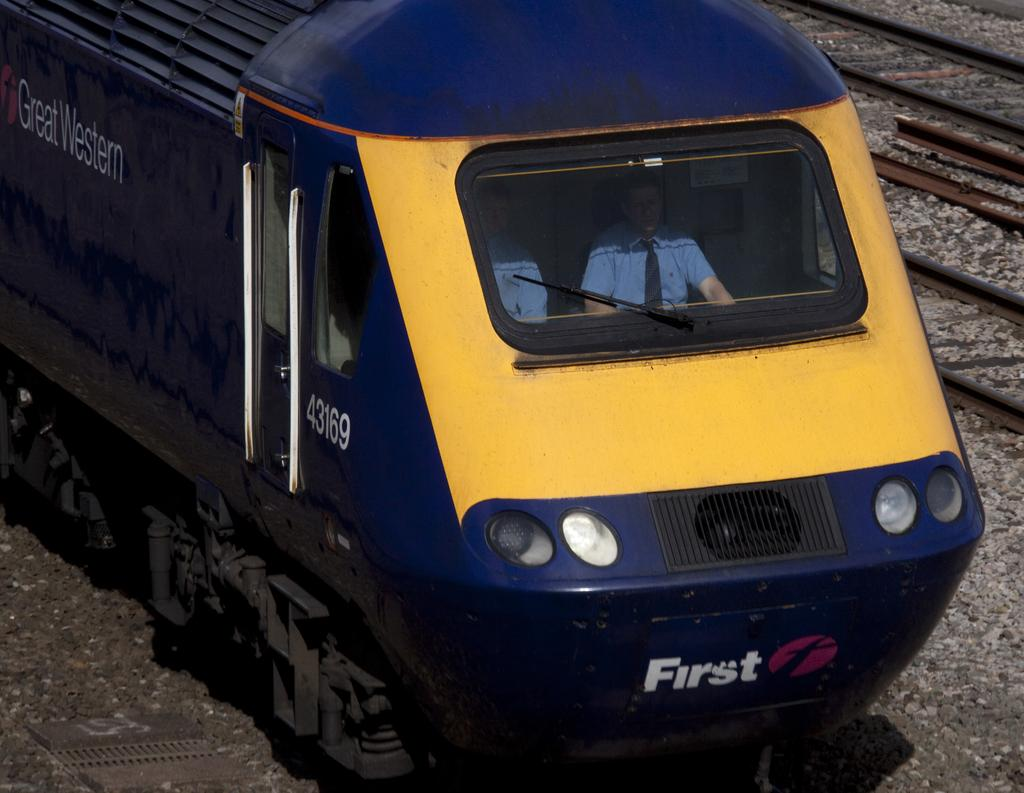What is the main subject of the image? The main subject of the image is a train. Where is the train located in the image? The train is on a rail track. How many people are visible inside the train? Two people are sitting in the train. What can be seen besides the train in the image? Rail tracks are visible in the image. What is the terrain like where the rail tracks are located? The rail tracks are on land with rocks. What type of branch is growing through the pipe in the image? There is no branch or pipe present in the image; it features a train on rail tracks with rocks. 